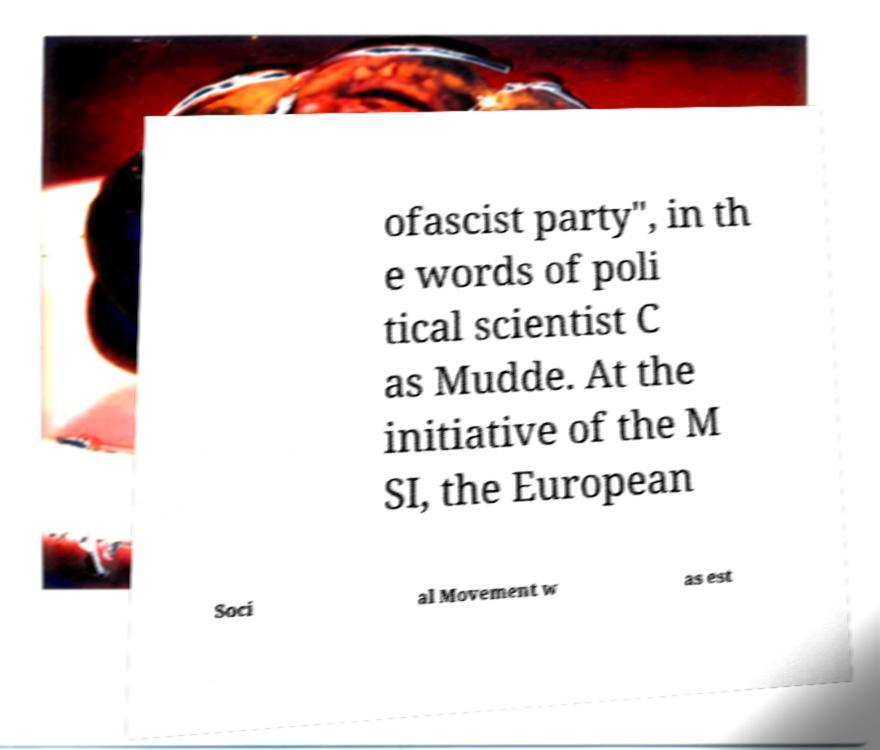Could you extract and type out the text from this image? ofascist party", in th e words of poli tical scientist C as Mudde. At the initiative of the M SI, the European Soci al Movement w as est 